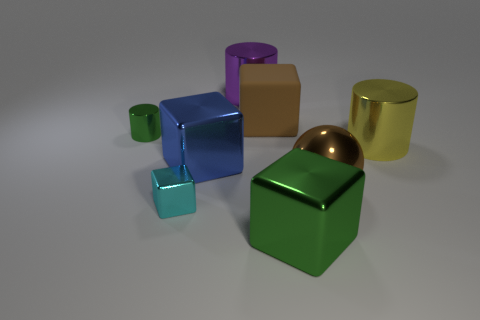Is the number of big blocks to the left of the small cyan cube greater than the number of big shiny things to the right of the blue metallic thing?
Ensure brevity in your answer.  No. Is there anything else that is the same color as the large matte cube?
Give a very brief answer. Yes. Are there any big green metallic objects on the left side of the large brown thing behind the cylinder on the left side of the large purple metal thing?
Ensure brevity in your answer.  No. There is a green thing that is in front of the tiny green cylinder; is it the same shape as the big brown rubber thing?
Your answer should be compact. Yes. Are there fewer big blue blocks to the left of the purple metallic cylinder than big brown balls that are to the left of the big blue block?
Provide a succinct answer. No. What is the large purple thing made of?
Make the answer very short. Metal. Is the color of the large sphere the same as the large shiny cube to the right of the purple object?
Provide a short and direct response. No. What number of green metal cylinders are on the right side of the small green cylinder?
Provide a short and direct response. 0. Is the number of large cylinders to the left of the large yellow thing less than the number of large matte cubes?
Offer a very short reply. No. The matte cube is what color?
Make the answer very short. Brown. 